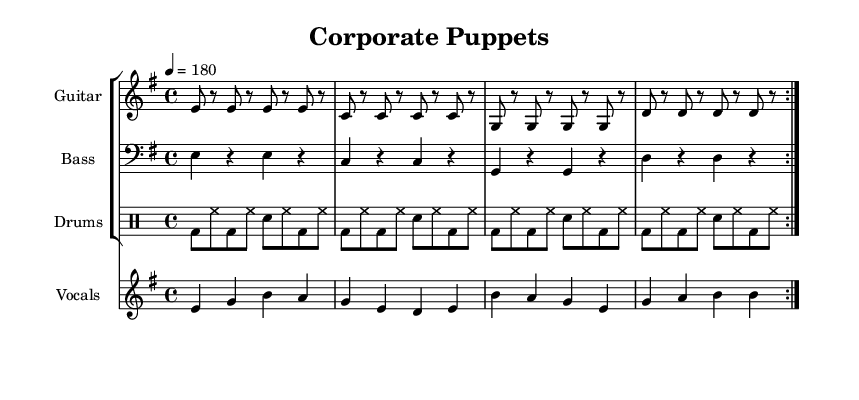What is the key signature of this music? The key signature is E minor, indicated by the presence of one sharp (F#) on the staff.
Answer: E minor What is the time signature of the music? The time signature is 4/4, which is a common time indicated at the beginning of the score.
Answer: 4/4 What is the tempo marking of the score? The tempo marking is 180 beats per minute, indicated by the notation "4 = 180" at the beginning of the score.
Answer: 180 How many measures are in the guitar riff section? The guitar riff consists of 8 measures, as indicated by the repeat signs and the structure of the sheet music.
Answer: 8 measures What are the lyrics for the chorus? The lyrics for the chorus are "We're not your puppets, we won't play along, Corporate influence, it's just so wrong". This can be found under the corresponding melody section.
Answer: We're not your puppets, we won't play along, Corporate influence, it's just so wrong What is the pattern of the drum part in the score? The drum part follows a consistent pattern that alternates between bass drums and snare drums, specifically using bass drum hits followed by hi-hat and snare. This is evident throughout the drum staff in the sheet music.
Answer: Alternating bass drum and snare What is the primary theme of the lyrics? The primary theme reflects an anti-establishment view, criticizing corporate influence in politics, as shown in the lyrics phrases indicating opposition to being controlled by corporate entities.
Answer: Anti-establishment 